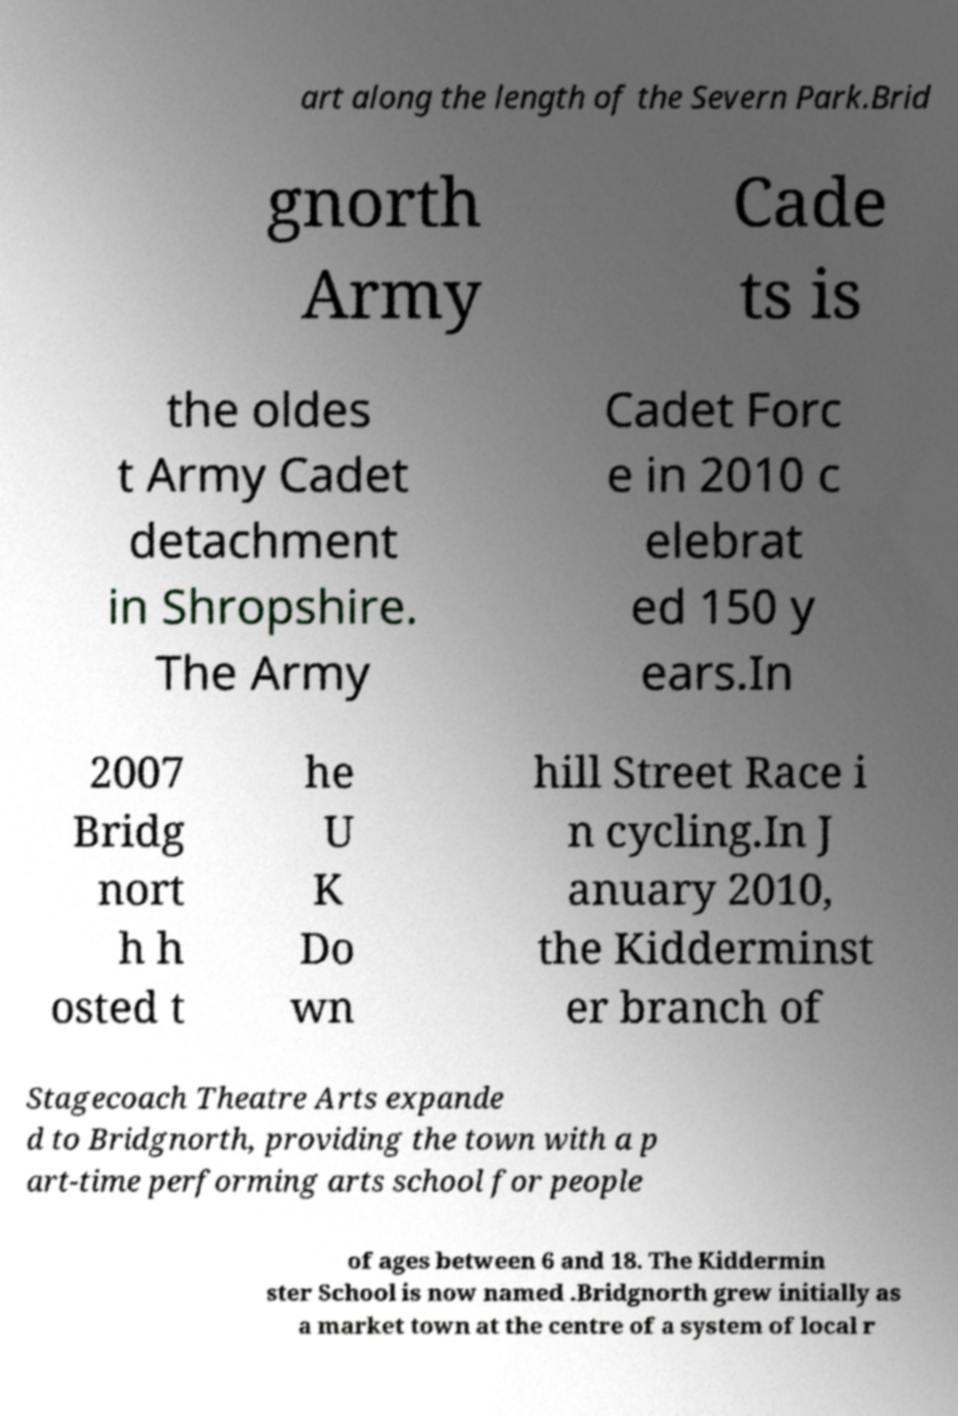Please read and relay the text visible in this image. What does it say? art along the length of the Severn Park.Brid gnorth Army Cade ts is the oldes t Army Cadet detachment in Shropshire. The Army Cadet Forc e in 2010 c elebrat ed 150 y ears.In 2007 Bridg nort h h osted t he U K Do wn hill Street Race i n cycling.In J anuary 2010, the Kidderminst er branch of Stagecoach Theatre Arts expande d to Bridgnorth, providing the town with a p art-time performing arts school for people of ages between 6 and 18. The Kiddermin ster School is now named .Bridgnorth grew initially as a market town at the centre of a system of local r 